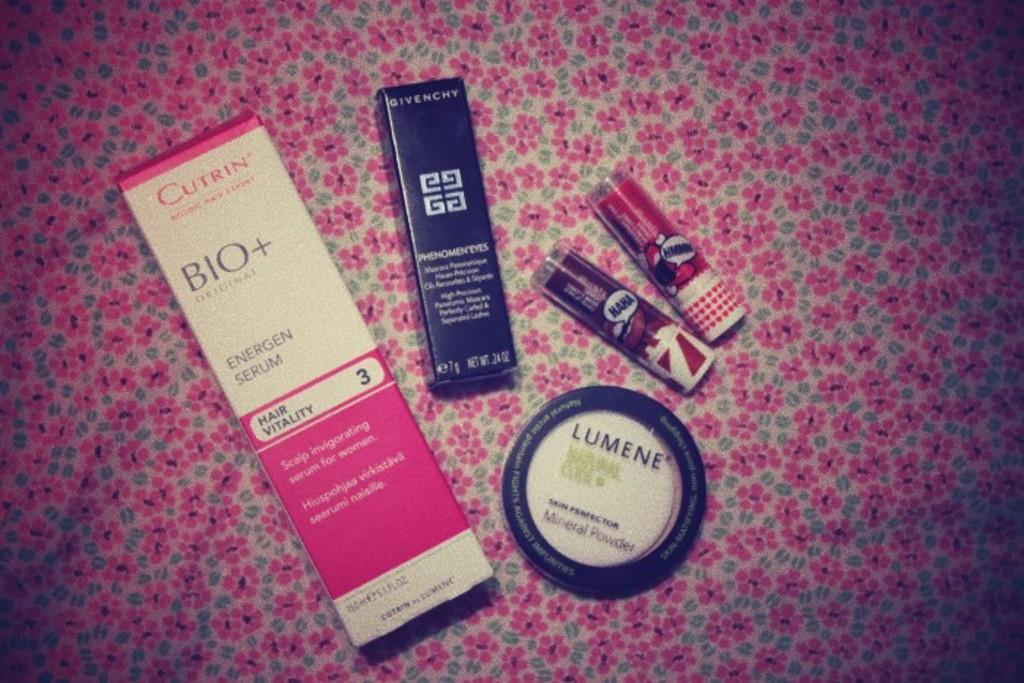<image>
Offer a succinct explanation of the picture presented. Some lumene powder and some other face products 